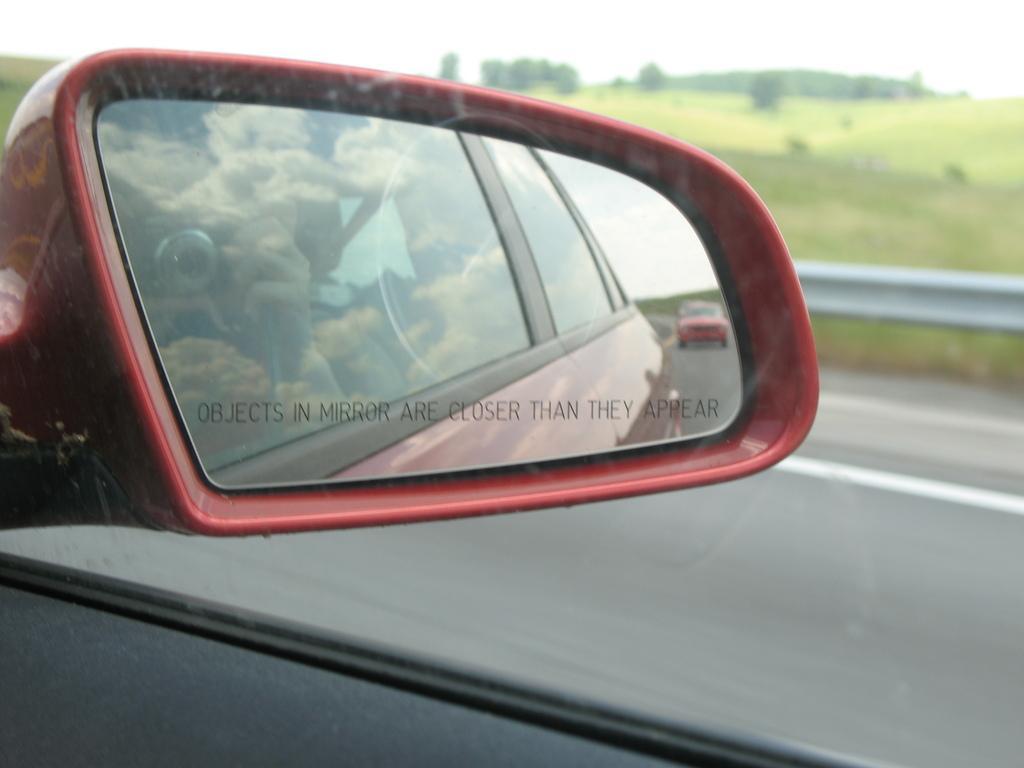Please provide a concise description of this image. In the picture we can see a vehicle side mirror with a red color frame to it and beside it, we can see a road and to it we can see railing and behind it, we can see the grass surface on it we can see some plants, hills and sky. 